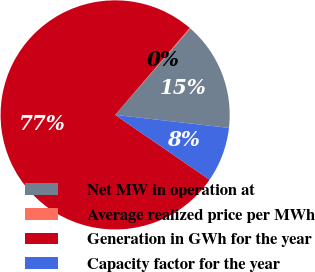Convert chart to OTSL. <chart><loc_0><loc_0><loc_500><loc_500><pie_chart><fcel>Net MW in operation at<fcel>Average realized price per MWh<fcel>Generation in GWh for the year<fcel>Capacity factor for the year<nl><fcel>15.42%<fcel>0.1%<fcel>76.72%<fcel>7.76%<nl></chart> 